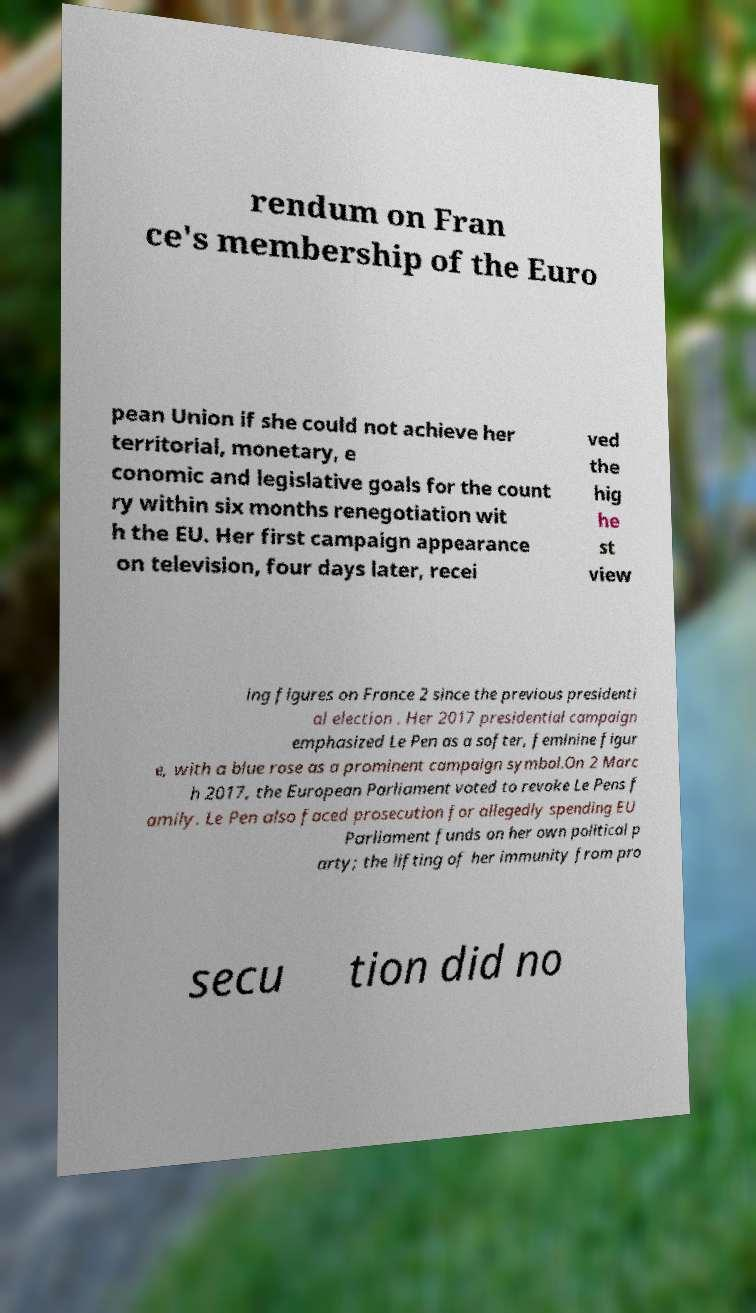Please identify and transcribe the text found in this image. rendum on Fran ce's membership of the Euro pean Union if she could not achieve her territorial, monetary, e conomic and legislative goals for the count ry within six months renegotiation wit h the EU. Her first campaign appearance on television, four days later, recei ved the hig he st view ing figures on France 2 since the previous presidenti al election . Her 2017 presidential campaign emphasized Le Pen as a softer, feminine figur e, with a blue rose as a prominent campaign symbol.On 2 Marc h 2017, the European Parliament voted to revoke Le Pens f amily. Le Pen also faced prosecution for allegedly spending EU Parliament funds on her own political p arty; the lifting of her immunity from pro secu tion did no 